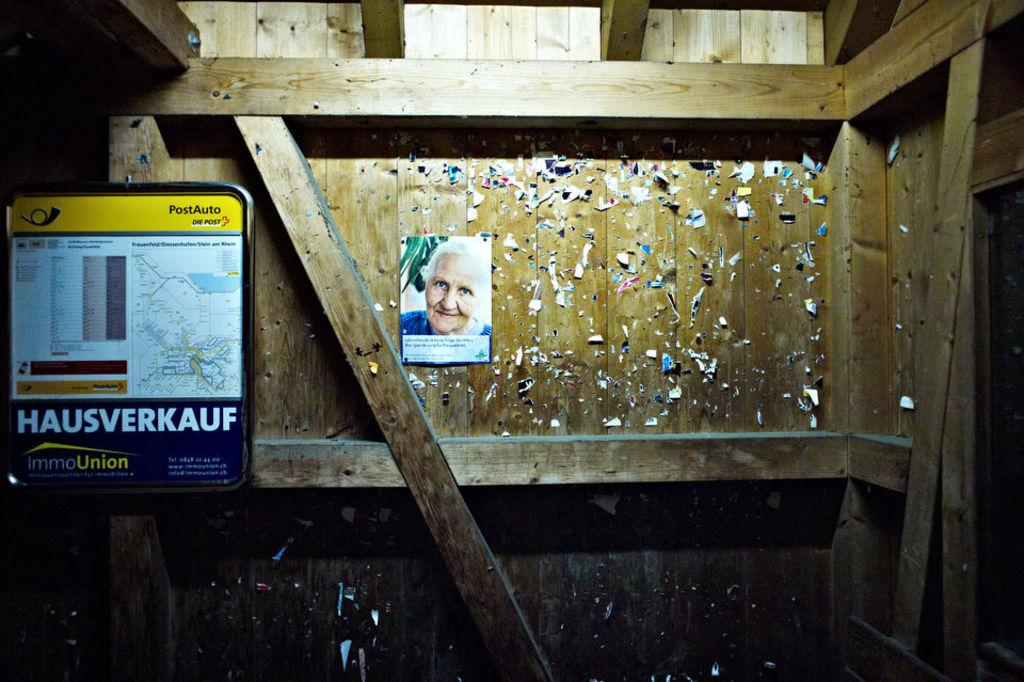What is hanging on the wooden wall in the image? There is a photo poster on a wooden wall in the image. What can be seen on the left side of the image? There is a board on the left side of the image. What type of vegetable is being used as a lamp in the image? There is no vegetable or lamp present in the image. What is being served for lunch in the image? There is no mention of lunch or any food items in the image. 